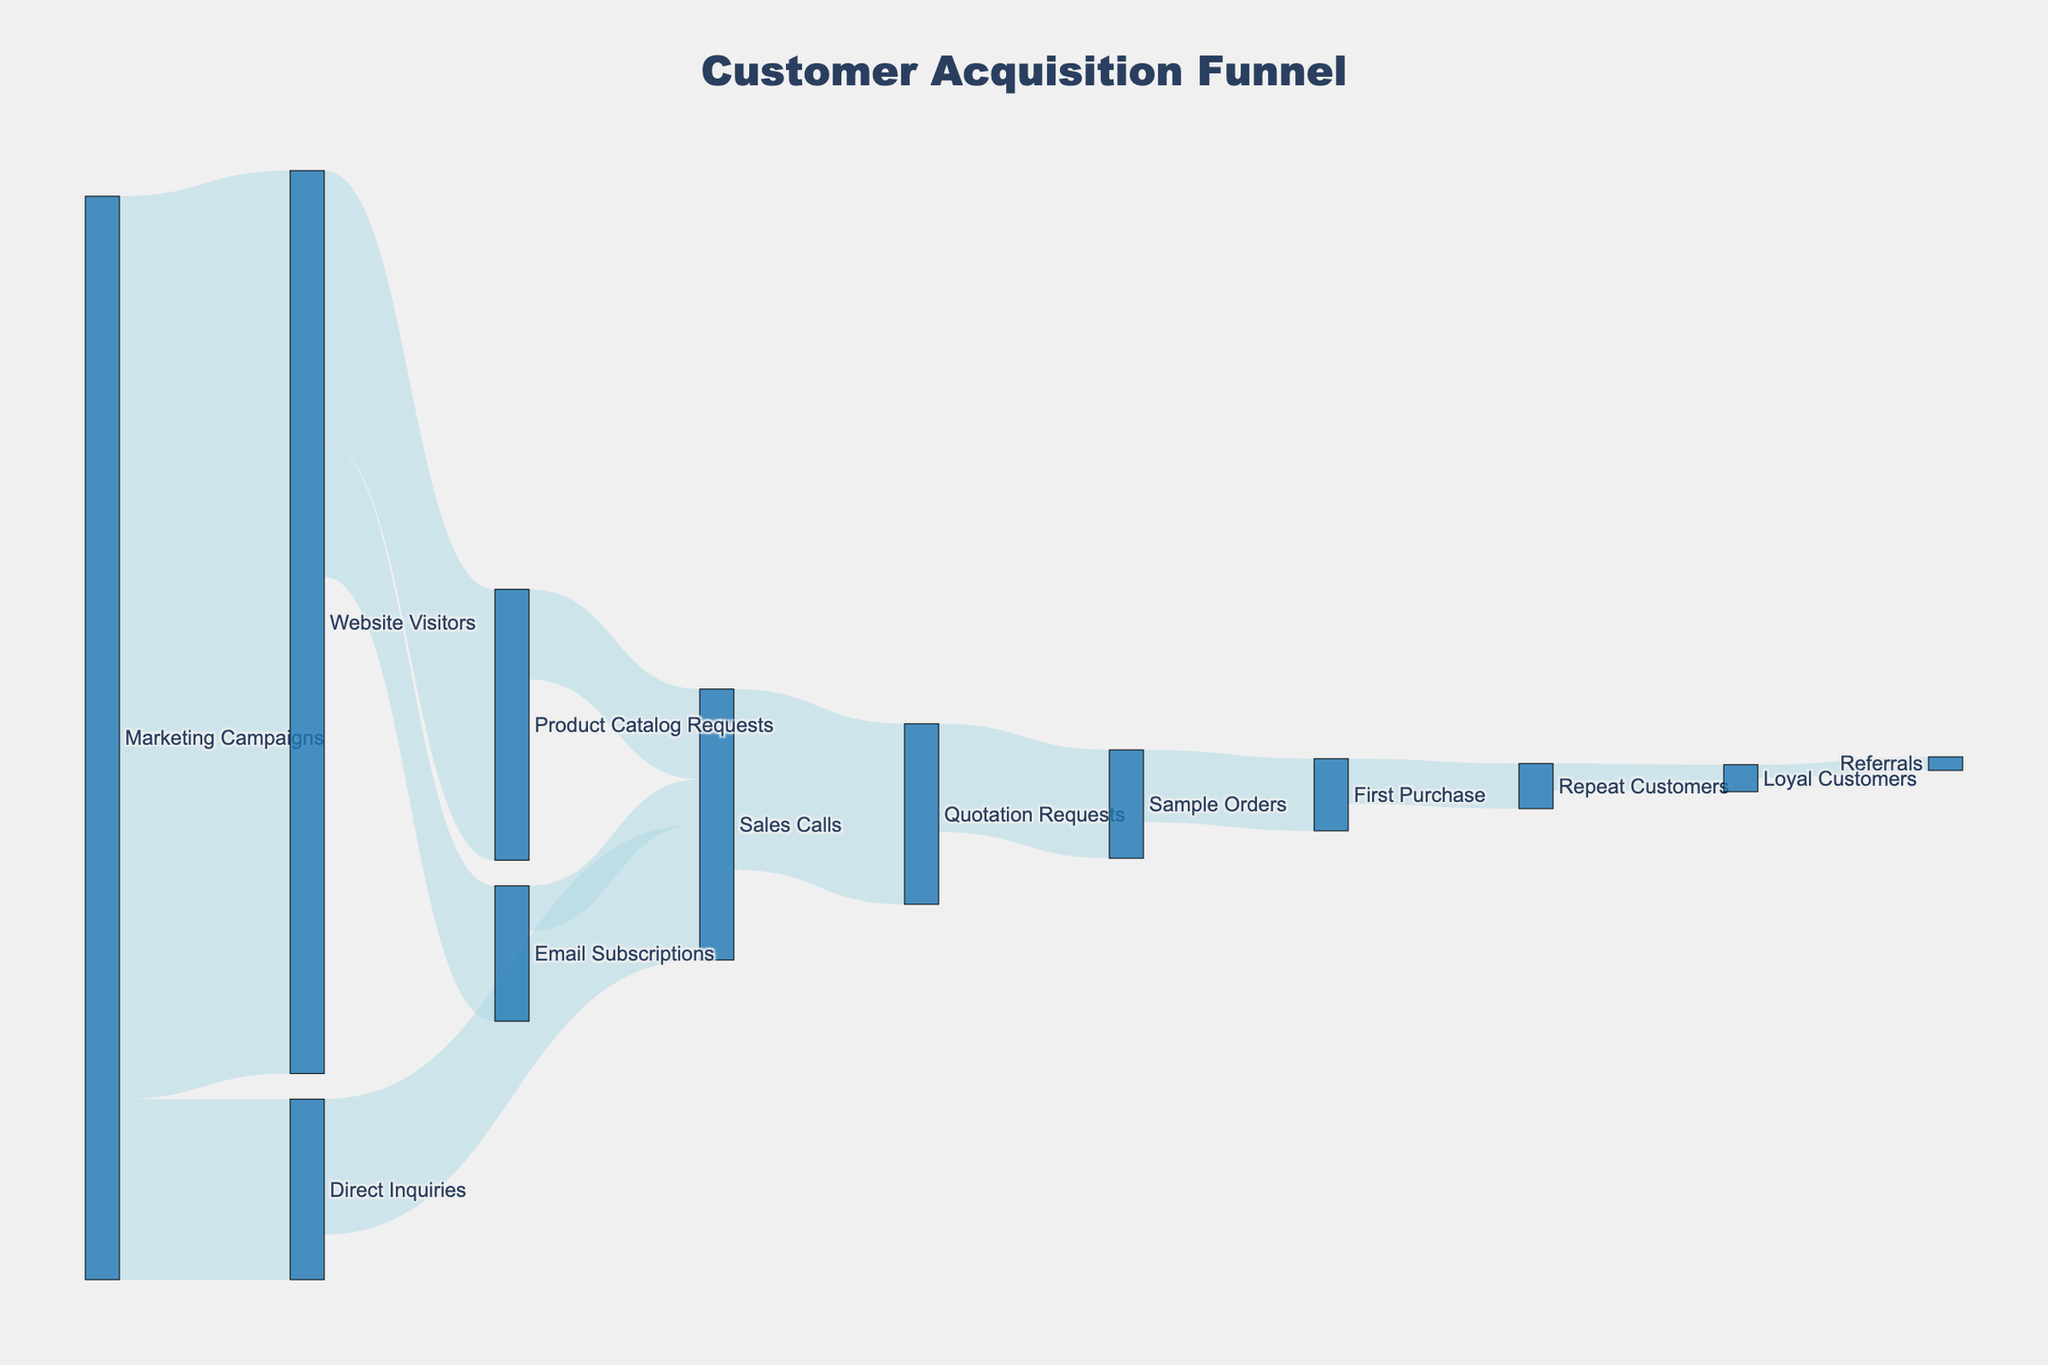How many visitors did the marketing campaigns bring to the website? The Sankey diagram shows a flow from "Marketing Campaigns" to "Website Visitors". The value associated with this flow represents the number of visitors brought by the marketing campaigns.
Answer: 1000 How many inquiries were generated directly from the marketing campaigns? The Sankey diagram shows a flow from "Marketing Campaigns" to "Direct Inquiries". The value associated with this flow represents the number of direct inquiries generated.
Answer: 200 What percentage of website visitors requested the product catalog? There were 300 product catalog requests from 1000 website visitors. To find the percentage, divide 300 by 1000 and multiply by 100. (300/1000) * 100 = 30%.
Answer: 30% What is the total number of sales calls made? From the Sankey diagram, find all paths leading to "Sales Calls": from "Direct Inquiries" (150), "Product Catalog Requests" (100), and "Email Subscriptions" (50). Summing these figures gives a total of 150 + 100 + 50 = 300.
Answer: 300 Which has more step conversions in the funnel, sample orders or first purchases? The diagram shows values for "Sample Orders" (120) and "First Purchase" (80). Comparing these, sample orders have a greater value (120 > 80).
Answer: Sample orders How many loyal customers resulted from the initial series of marketing campaigns? Follow the flow leading to "Loyal Customers". The flow paths funnel through "Marketing Campaigns" leading to "Website Visitors", "Direct Inquiries", "Sales Calls", "Quotation Requests", "Sample Orders", "First Purchase", "Repeat Customers", then "Loyal Customers". The direct value shown for "Loyal Customers" is 30.
Answer: 30 What proportion of quotation requests led to sample orders? "Quotation Requests" value is 200 and "Sample Orders" value is 120. The proportion is found by dividing 120 by 200. (120/200) = 0.6 or 60%.
Answer: 60% Which segment contributed the least to sales calls? From "Direct Inquiries", "Product Catalog Requests", and "Email Subscriptions" leading to "Sales Calls", the smallest contributing segment is "Email Subscriptions" with a value of 50.
Answer: Email Subscriptions How many referrals came from loyal customers? The diagram shows a direct flow from "Loyal Customers" to "Referrals" with a value of 15.
Answer: 15 What is the drop-off rate from repeat customers to referrals? "Repeat Customers" has a value of 50 and "Referrals" has a value of 15. The drop-off rate is calculated as (50 - 15) / 50 * 100, which equals 70%.
Answer: 70% 